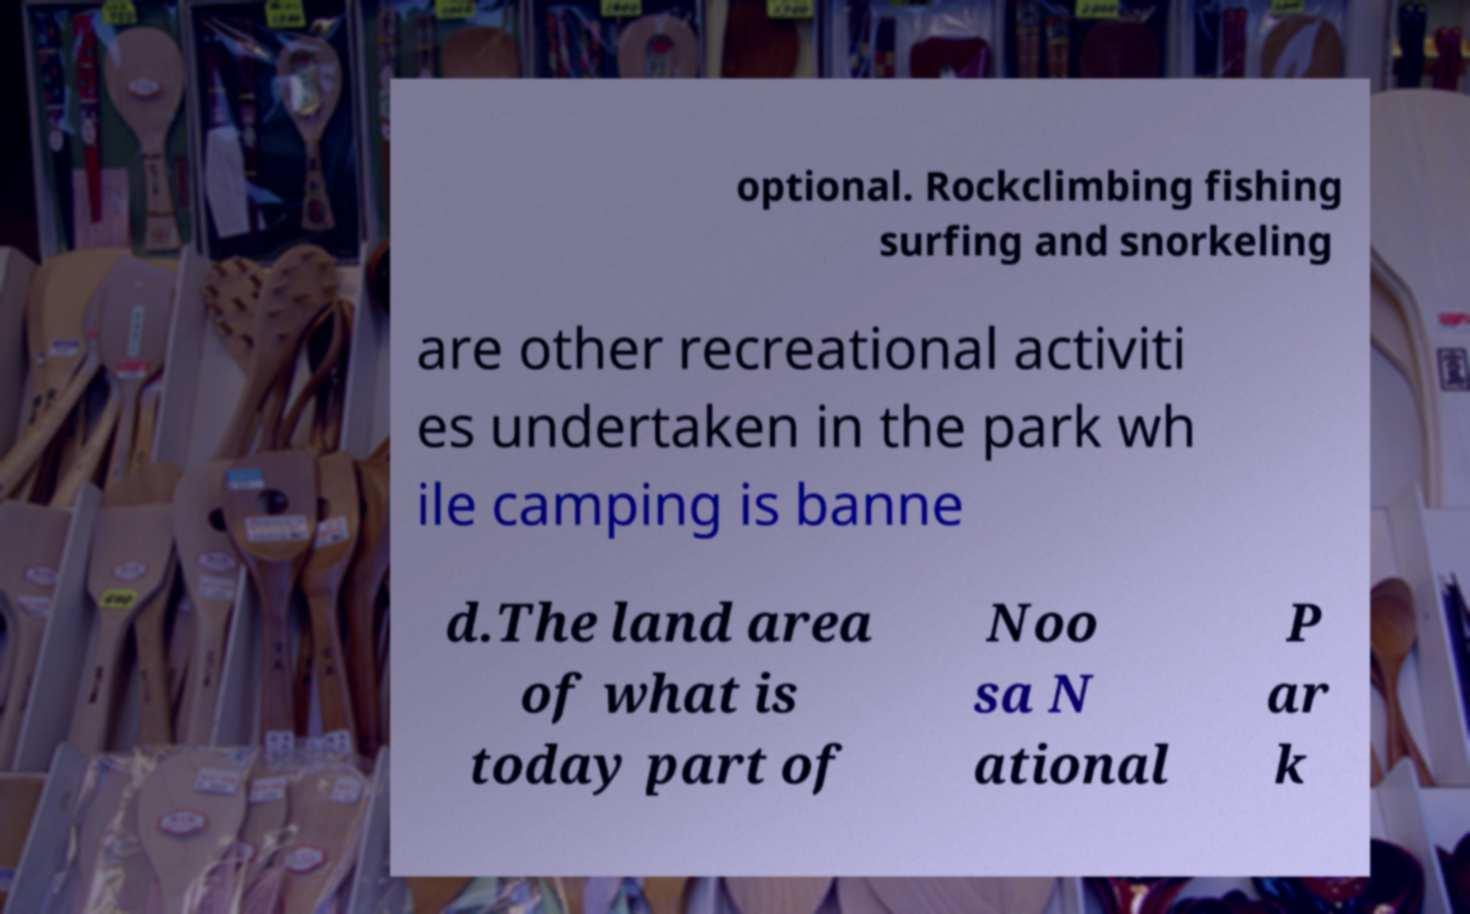Could you assist in decoding the text presented in this image and type it out clearly? optional. Rockclimbing fishing surfing and snorkeling are other recreational activiti es undertaken in the park wh ile camping is banne d.The land area of what is today part of Noo sa N ational P ar k 